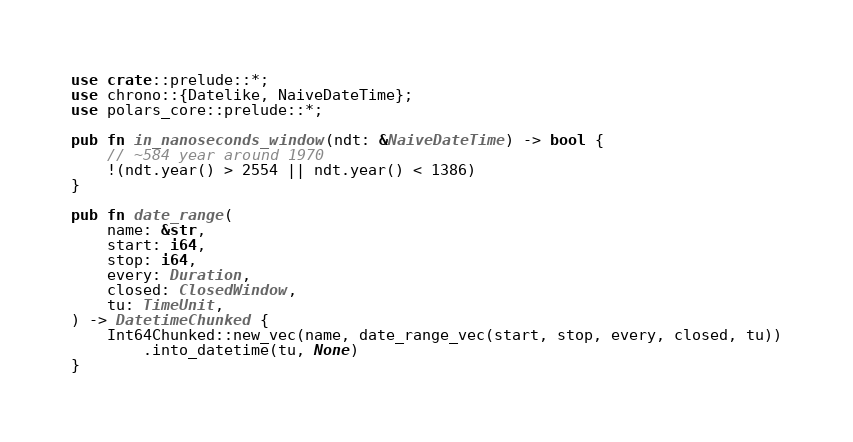<code> <loc_0><loc_0><loc_500><loc_500><_Rust_>use crate::prelude::*;
use chrono::{Datelike, NaiveDateTime};
use polars_core::prelude::*;

pub fn in_nanoseconds_window(ndt: &NaiveDateTime) -> bool {
    // ~584 year around 1970
    !(ndt.year() > 2554 || ndt.year() < 1386)
}

pub fn date_range(
    name: &str,
    start: i64,
    stop: i64,
    every: Duration,
    closed: ClosedWindow,
    tu: TimeUnit,
) -> DatetimeChunked {
    Int64Chunked::new_vec(name, date_range_vec(start, stop, every, closed, tu))
        .into_datetime(tu, None)
}
</code> 